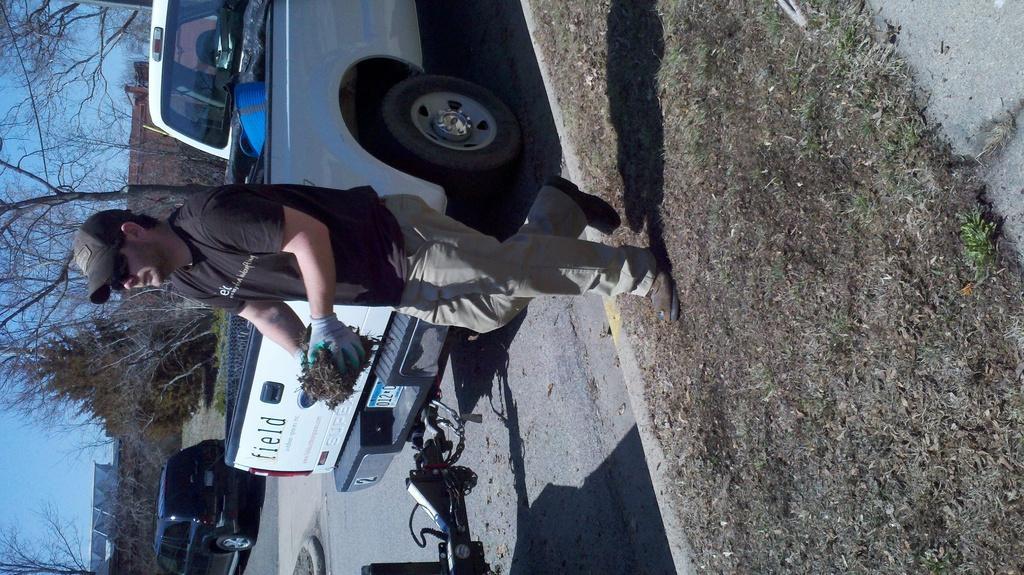Describe this image in one or two sentences. In this image, we can see some cars and there is a person standing, we can see some trees and there is a sky. 